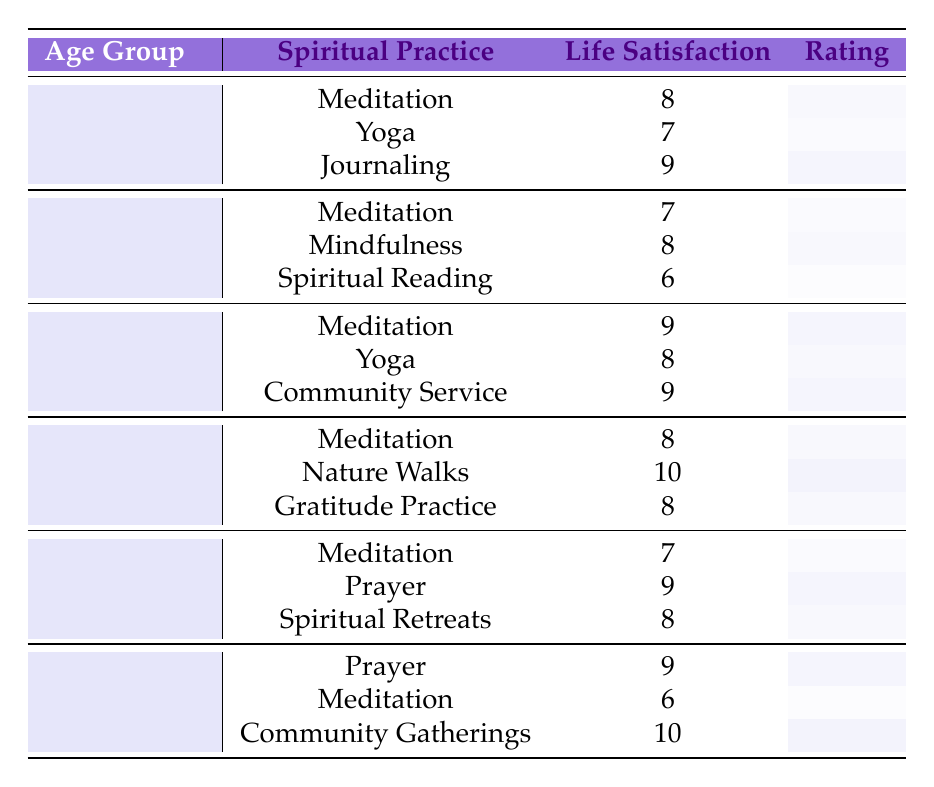What is the life satisfaction rating for Meditation in the age group 35-44? In the table, under the age group 35-44, the row for Meditation shows a Life Satisfaction Rating of 9.
Answer: 9 Which spiritual practice has the highest life satisfaction rating in the age group 45-54? Looking at the age group 45-54, the practice with the highest rating is Nature Walks, which has a rating of 10.
Answer: Nature Walks What is the average life satisfaction rating for the age group 55-64? To find the average for this age group: (7 + 9 + 8) / 3 = 24 / 3 = 8. The three ratings are 7 (Meditation), 9 (Prayer), and 8 (Spiritual Retreats).
Answer: 8 Is there any age group where Community Service has a life satisfaction rating? Examining the table, Community Service is listed under the age group 35-44 with a rating of 9. Therefore, the answer is yes.
Answer: Yes What is the difference in life satisfaction ratings between Yoga and Journaling for the age group 18-24? For the age group 18-24, Yoga has a rating of 7 and Journaling has a rating of 9. To find the difference, we subtract: 9 - 7 = 2.
Answer: 2 Which spiritual practice yields the lowest life satisfaction rating across all age groups? The lowest rating in the entire table is for Spiritual Reading in the age group 25-34, which has a rating of 6.
Answer: Spiritual Reading How many spiritual practices achieve a life satisfaction rating of 10? The table shows that there are two practices with a rating of 10: Nature Walks in the age group 45-54 and Community Gatherings in the age group 65 and above. So there are 2 practices.
Answer: 2 What is the highest life satisfaction rating for the age group 18-24, and which practice corresponds to it? Among the practices in the age group 18-24, the highest rating is 9 for Journaling.
Answer: 9 for Journaling Which age group generally has higher life satisfaction ratings, 25-34 or 35-44? Comparing the two age groups: average for 25-34 is (7 + 8 + 6) / 3 = 21 / 3 = 7, and for 35-44 it is (9 + 8 + 9) / 3 = 26 / 3 = 8.67. Since 8.67 is higher, age group 35-44 generally has higher ratings.
Answer: 35-44 